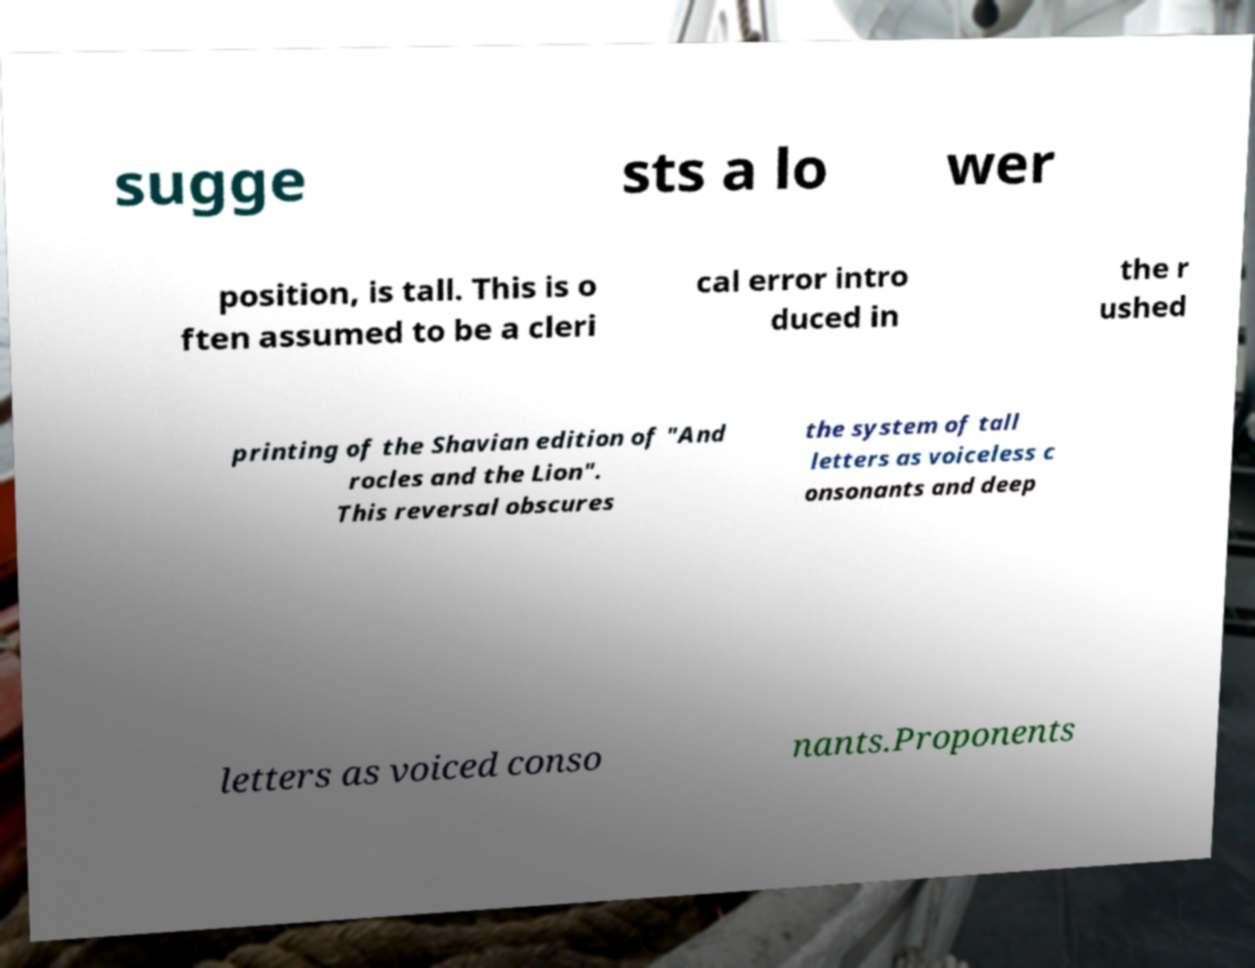For documentation purposes, I need the text within this image transcribed. Could you provide that? sugge sts a lo wer position, is tall. This is o ften assumed to be a cleri cal error intro duced in the r ushed printing of the Shavian edition of "And rocles and the Lion". This reversal obscures the system of tall letters as voiceless c onsonants and deep letters as voiced conso nants.Proponents 